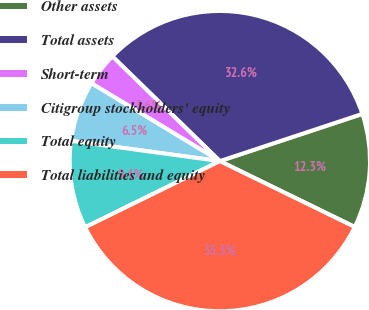<chart> <loc_0><loc_0><loc_500><loc_500><pie_chart><fcel>Other assets<fcel>Total assets<fcel>Short-term<fcel>Citigroup stockholders' equity<fcel>Total equity<fcel>Total liabilities and equity<nl><fcel>12.32%<fcel>32.62%<fcel>3.62%<fcel>6.52%<fcel>9.42%<fcel>35.51%<nl></chart> 